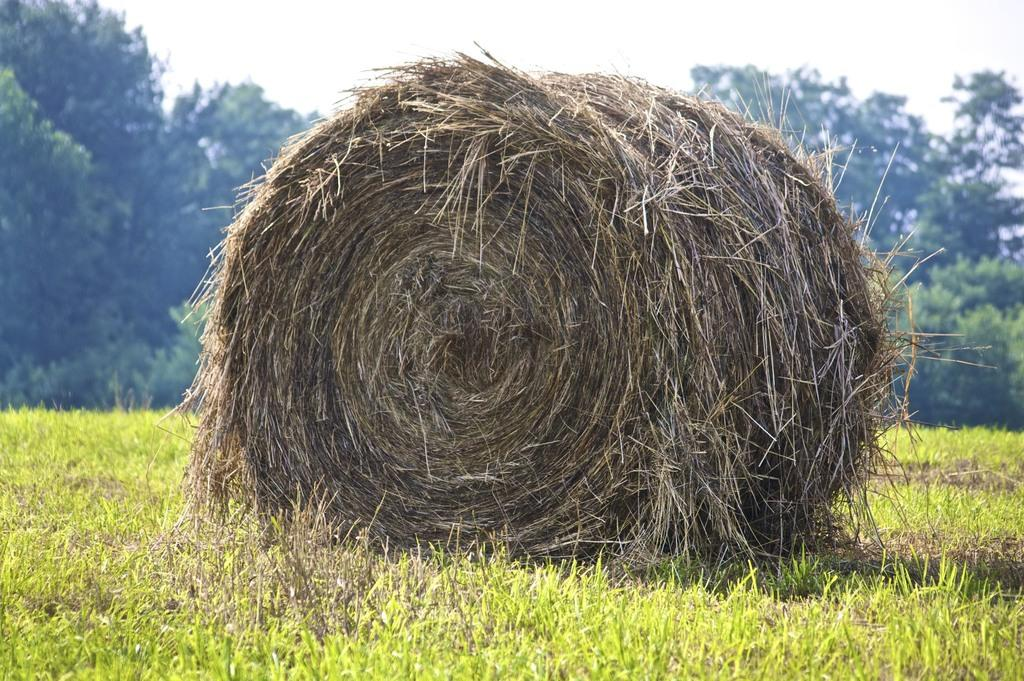What type of vegetation is in the middle of the image? There are trees in the middle of the image. What type of ground cover is present in the image? There is grass in the middle and bottom of the image. What is visible at the top of the image? The sky is visible at the top of the image. What word is written in the caption of the image? There is no caption present in the image, so it is not possible to answer that question. 